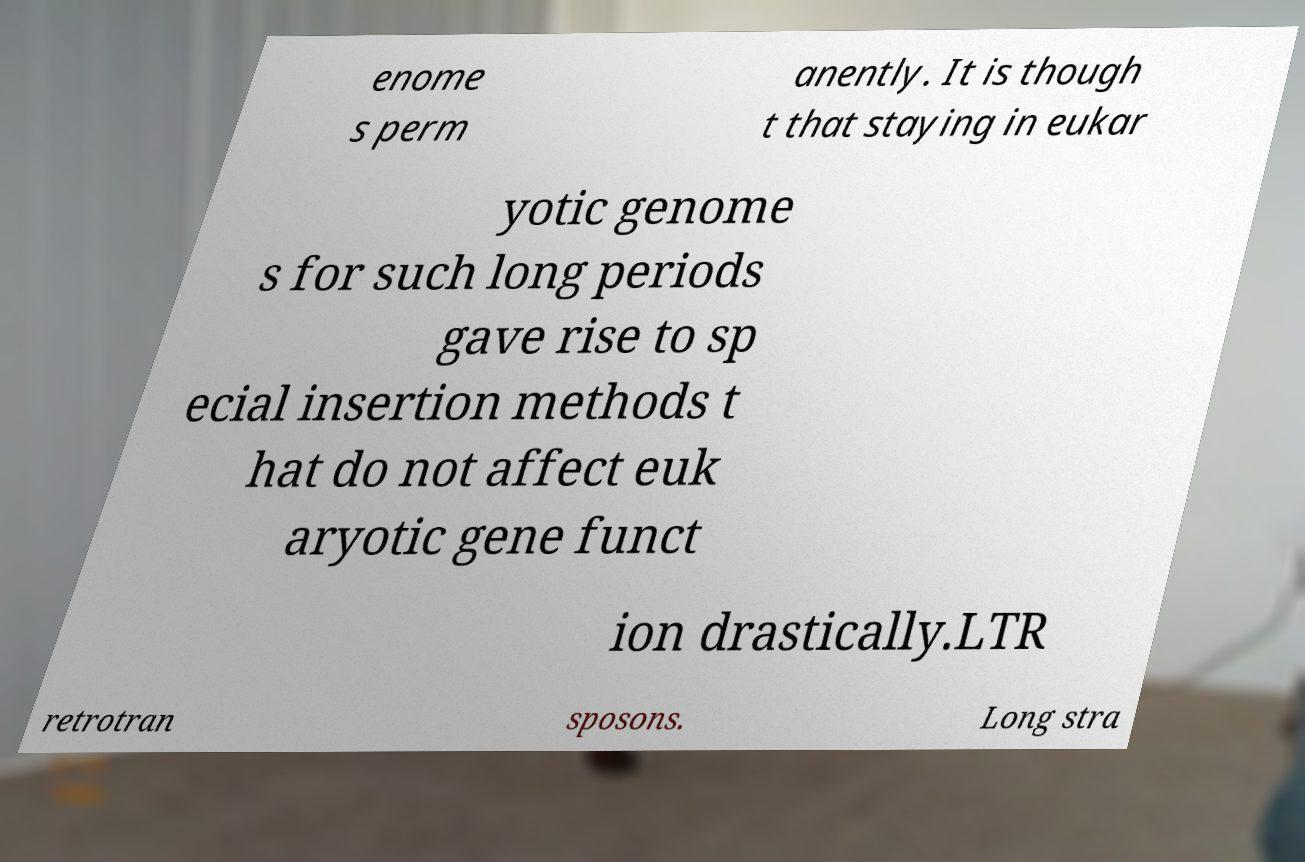Please identify and transcribe the text found in this image. enome s perm anently. It is though t that staying in eukar yotic genome s for such long periods gave rise to sp ecial insertion methods t hat do not affect euk aryotic gene funct ion drastically.LTR retrotran sposons. Long stra 